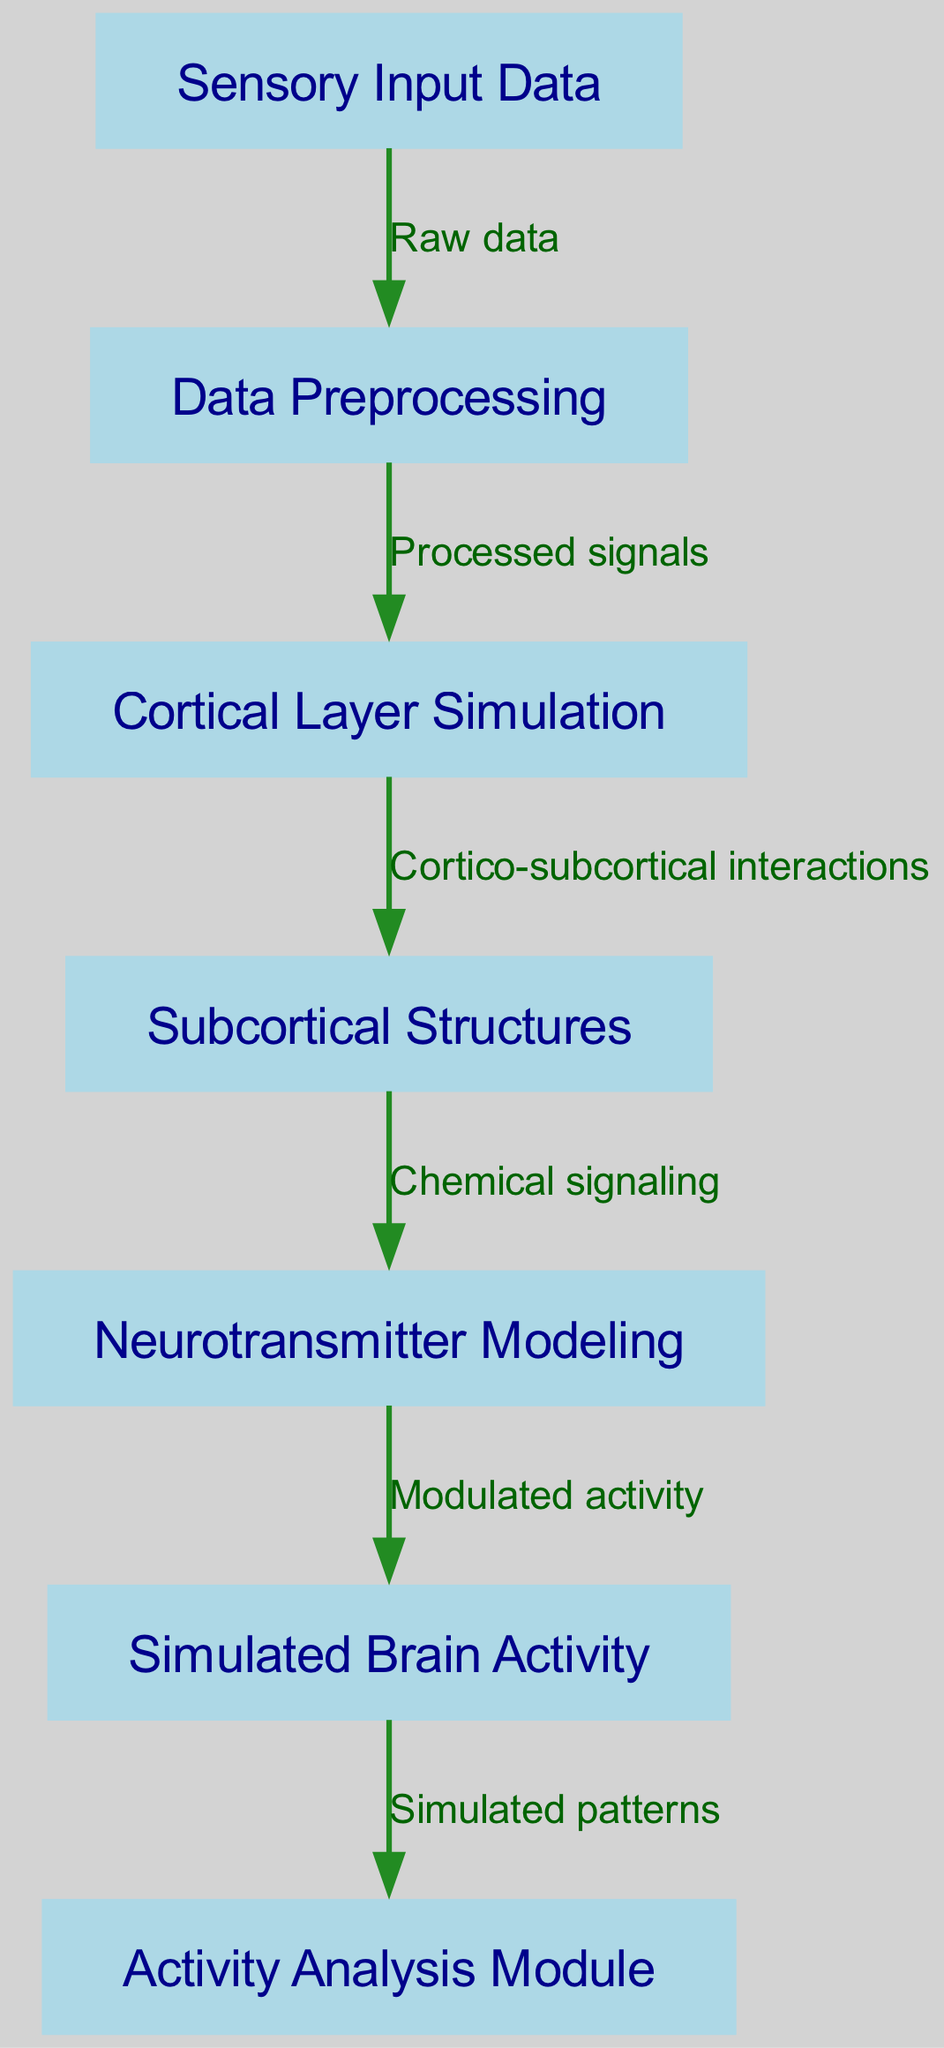What is the first node in the diagram? The first node represents the initial stage where sensory input data is introduced into the system, starting the process. In the diagram, this node is labeled "Sensory Input Data."
Answer: Sensory Input Data How many nodes are there in total? By counting each listed node in the data, we find there are seven distinct nodes: Sensory Input Data, Data Preprocessing, Cortical Layer Simulation, Subcortical Structures, Neurotransmitter Modeling, Simulated Brain Activity, and Activity Analysis Module.
Answer: Seven What type of connection exists between the preprocessing and cortical layer nodes? The relationship between preprocessing and cortical layer nodes is indicated by an edge labeled "Processed signals," showing that the output from the preprocessing node is directed into the cortical layer simulation node.
Answer: Processed signals Which module analyzes the simulated brain activity? The module responsible for analyzing the simulated brain activity is the last node in the diagram, labeled "Activity Analysis Module." This node receives the output from the simulated brain activity node for further insights.
Answer: Activity Analysis Module What kind of signaling is referenced between subcortical and neurotransmitter nodes? The edge connecting the subcortical structures and neurotransmitter modeling is labeled "Chemical signaling," indicating the interaction type in the neural simulation process.
Answer: Chemical signaling What is the ultimate output of the neural network architecture? The final output from the entire architectural flow, as indicated by the diagram, is labeled "Simulated Brain Activity," which aggregates the previous processes' results.
Answer: Simulated Brain Activity How many edges are defined in the diagram? By counting each specified edge in the data, we observe there are six directed connections that illustrate the flow of information between the nodes.
Answer: Six 